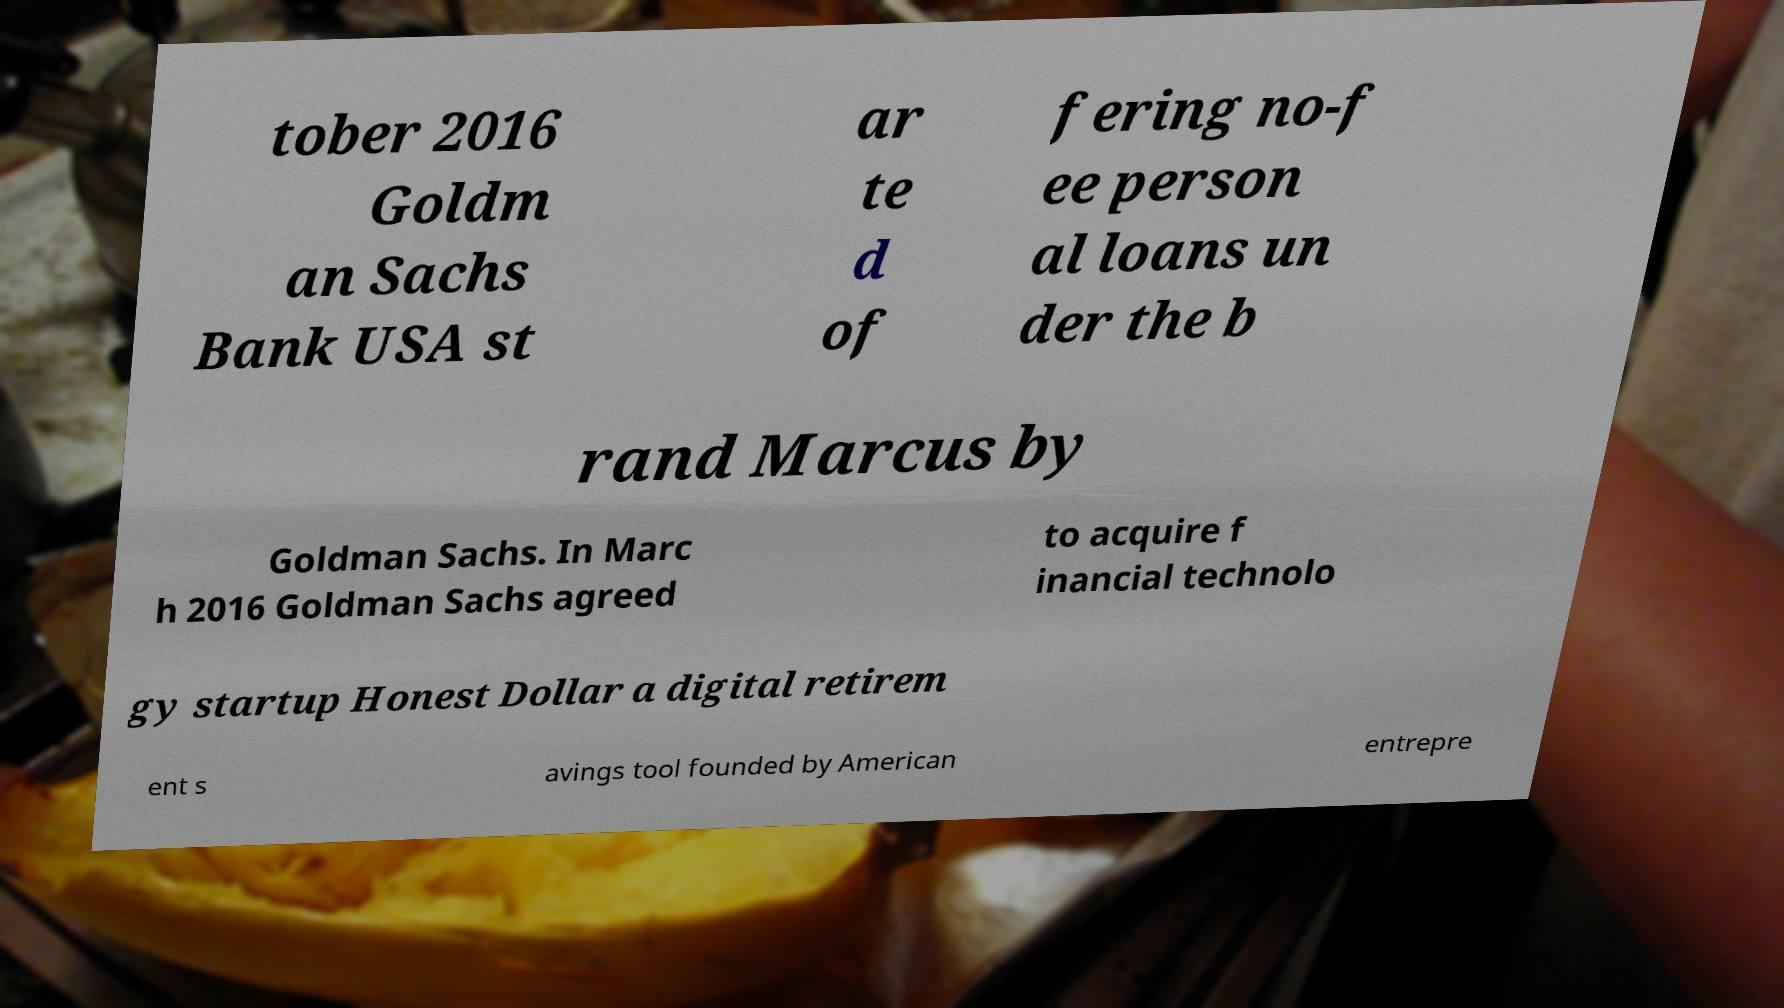Please read and relay the text visible in this image. What does it say? tober 2016 Goldm an Sachs Bank USA st ar te d of fering no-f ee person al loans un der the b rand Marcus by Goldman Sachs. In Marc h 2016 Goldman Sachs agreed to acquire f inancial technolo gy startup Honest Dollar a digital retirem ent s avings tool founded by American entrepre 